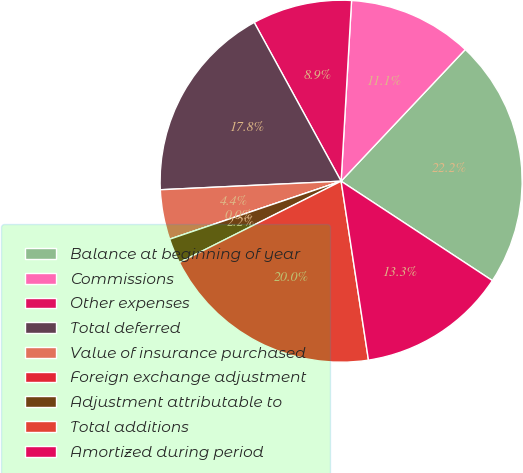Convert chart. <chart><loc_0><loc_0><loc_500><loc_500><pie_chart><fcel>Balance at beginning of year<fcel>Commissions<fcel>Other expenses<fcel>Total deferred<fcel>Value of insurance purchased<fcel>Foreign exchange adjustment<fcel>Adjustment attributable to<fcel>Total additions<fcel>Amortized during period<nl><fcel>22.22%<fcel>11.11%<fcel>8.89%<fcel>17.78%<fcel>4.44%<fcel>0.0%<fcel>2.22%<fcel>20.0%<fcel>13.33%<nl></chart> 